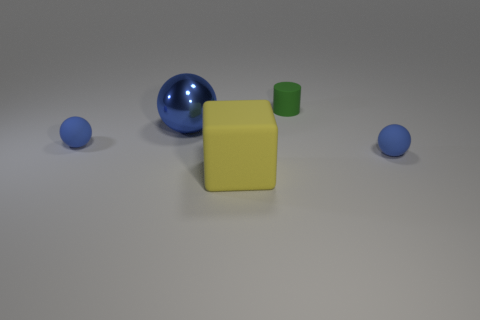Subtract all blue spheres. How many were subtracted if there are1blue spheres left? 2 Add 1 big metal things. How many objects exist? 6 Subtract all spheres. How many objects are left? 2 Subtract 0 gray balls. How many objects are left? 5 Subtract all big green rubber spheres. Subtract all blue things. How many objects are left? 2 Add 3 large blue spheres. How many large blue spheres are left? 4 Add 1 big green metallic spheres. How many big green metallic spheres exist? 1 